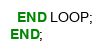<code> <loc_0><loc_0><loc_500><loc_500><_SQL_>  END LOOP;
END;


</code> 